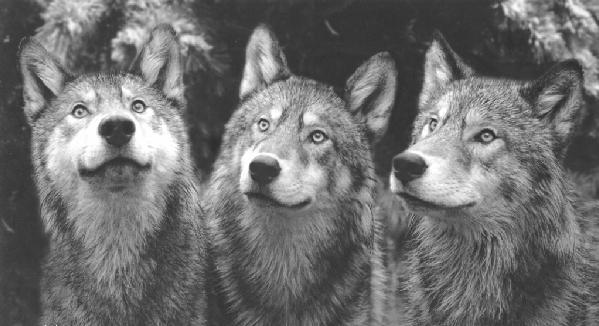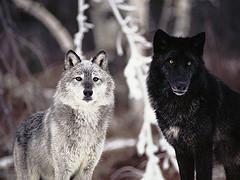The first image is the image on the left, the second image is the image on the right. Analyze the images presented: Is the assertion "At least one of the wolves is looking straight at the camera." valid? Answer yes or no. Yes. The first image is the image on the left, the second image is the image on the right. Evaluate the accuracy of this statement regarding the images: "The left image contains at least two wolves.". Is it true? Answer yes or no. Yes. 